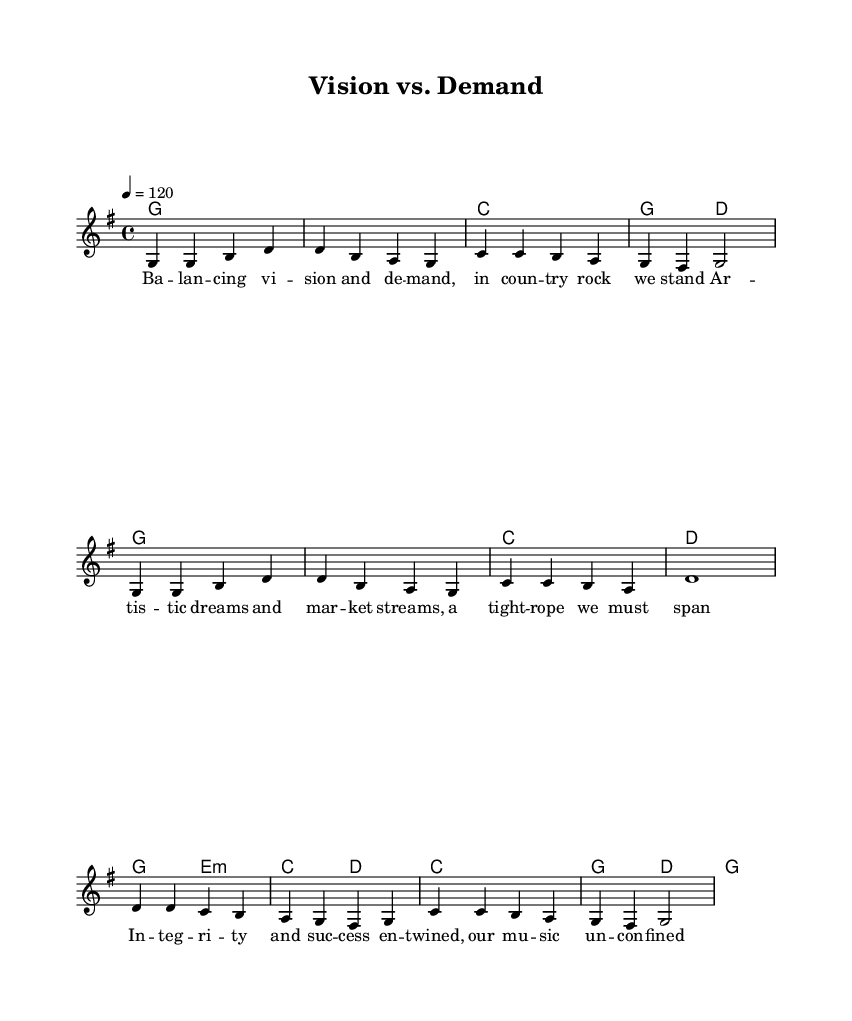What is the key signature of this music? The key signature shows one sharp (F#), which indicates G major.
Answer: G major What is the time signature of this music? The time signature is indicated by the rhythm at the beginning of the staff, showing four beats per measure.
Answer: 4/4 What is the tempo marking for this piece? The tempo marking is shown at the beginning of the score, indicating a speed of 120 beats per minute.
Answer: 120 How many measures are in the melody? By counting the bar lines in the melody, there are a total of 8 measures visible.
Answer: 8 What is the chord progression used in the first line? The chords in the first line are visually listed under the melody, showing G, G, C, G.
Answer: G, G, C, G What lyrical theme is presented in the song? The lyrics discuss the balance between artistic vision and market demands, focusing on integrity and success.
Answer: Balance between vision and demand How does the melody reflect the style of Country Rock? The use of simple, catchy phrases and repetitive patterns in the melody are characteristic of Country Rock music, appealing to a broader audience.
Answer: Simple and catchy 